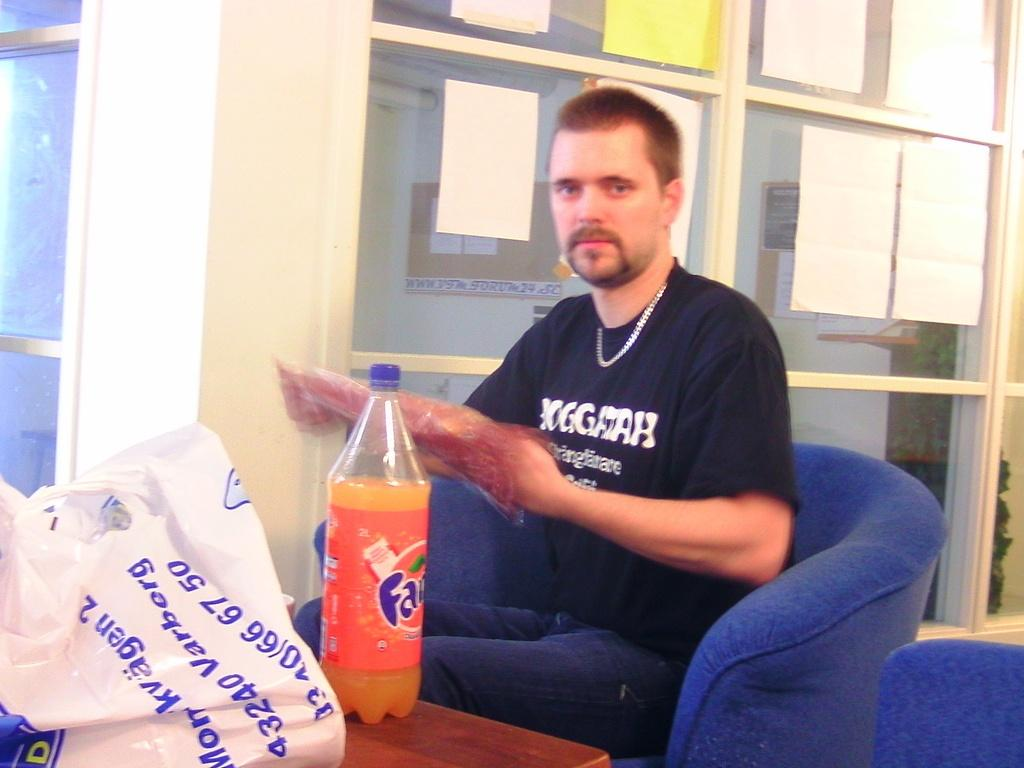Who is present in the image? There is a man in the image. What is the man sitting on? The man is sitting on a blue chair. What is in front of the man? There is a table in front of the man. What can be seen on the table? There is a Fantа bottle and a plastic cover on the table. What type of camera is being used to capture the man's theory in the image? There is no camera or theory present in the image; it simply shows a man sitting on a blue chair with a table in front of him. 